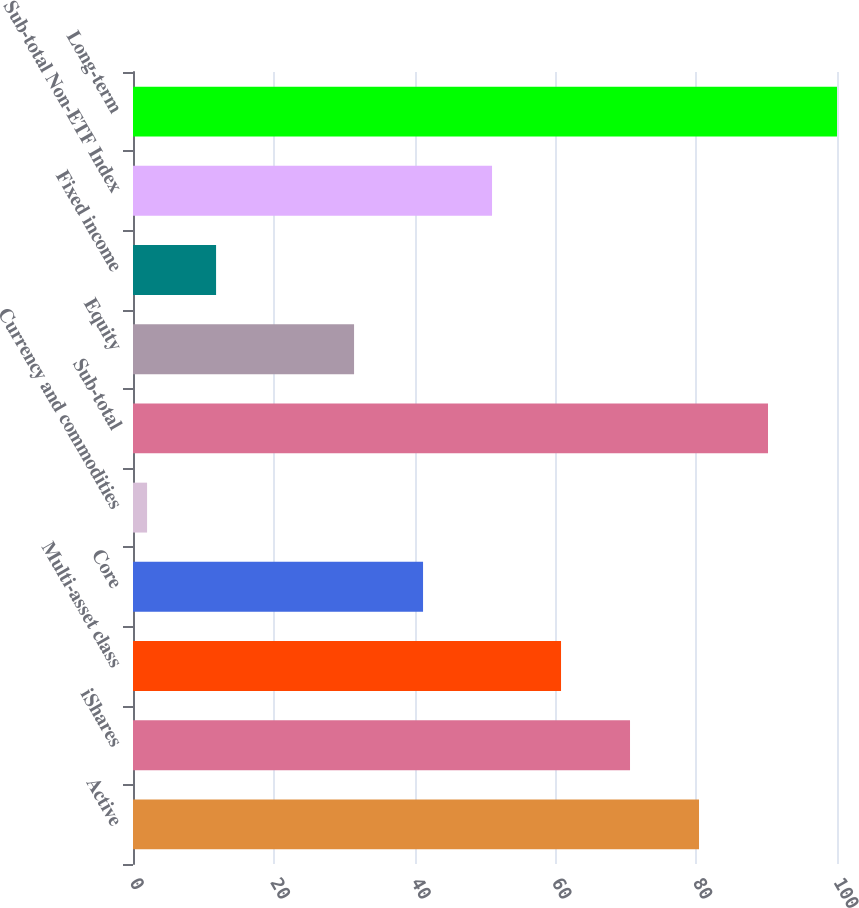Convert chart to OTSL. <chart><loc_0><loc_0><loc_500><loc_500><bar_chart><fcel>Active<fcel>iShares<fcel>Multi-asset class<fcel>Core<fcel>Currency and commodities<fcel>Sub-total<fcel>Equity<fcel>Fixed income<fcel>Sub-total Non-ETF Index<fcel>Long-term<nl><fcel>80.4<fcel>70.6<fcel>60.8<fcel>41.2<fcel>2<fcel>90.2<fcel>31.4<fcel>11.8<fcel>51<fcel>100<nl></chart> 